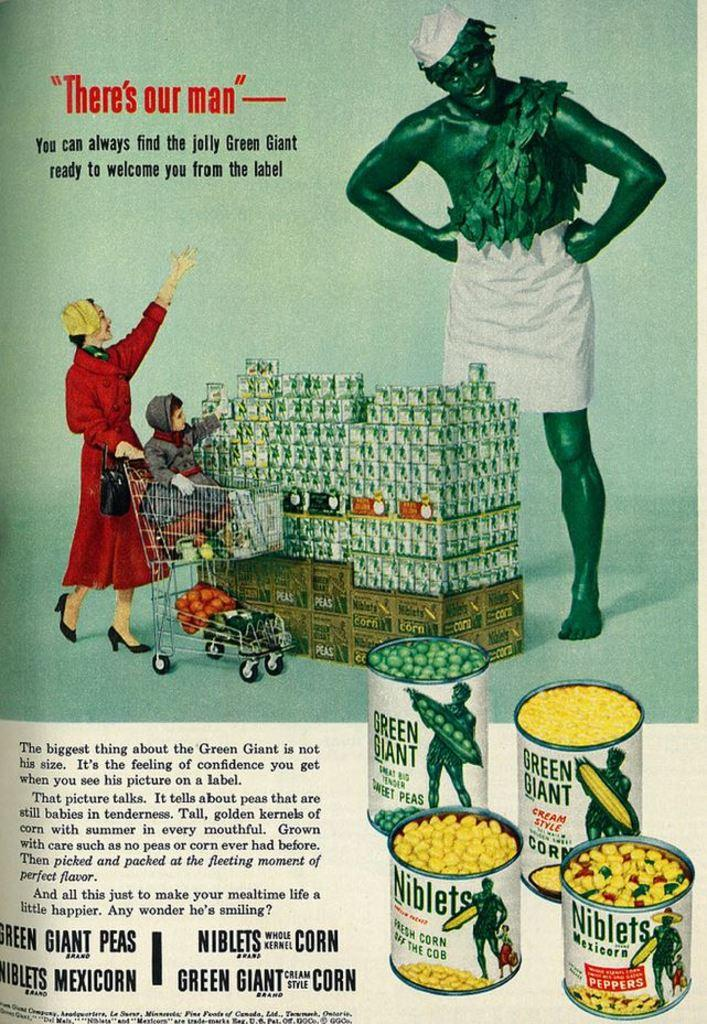What is featured on the poster in the image? The poster in the image has two persons and a kid. What else can be seen in the image besides the poster? There is a box in the image. What is inside the box? The box contains peas and corns. How many slaves are depicted on the poster? There are no slaves depicted on the poster; it features two persons and a kid. What type of plant is growing in the box? There is no plant growing in the box; it contains peas and corns. 